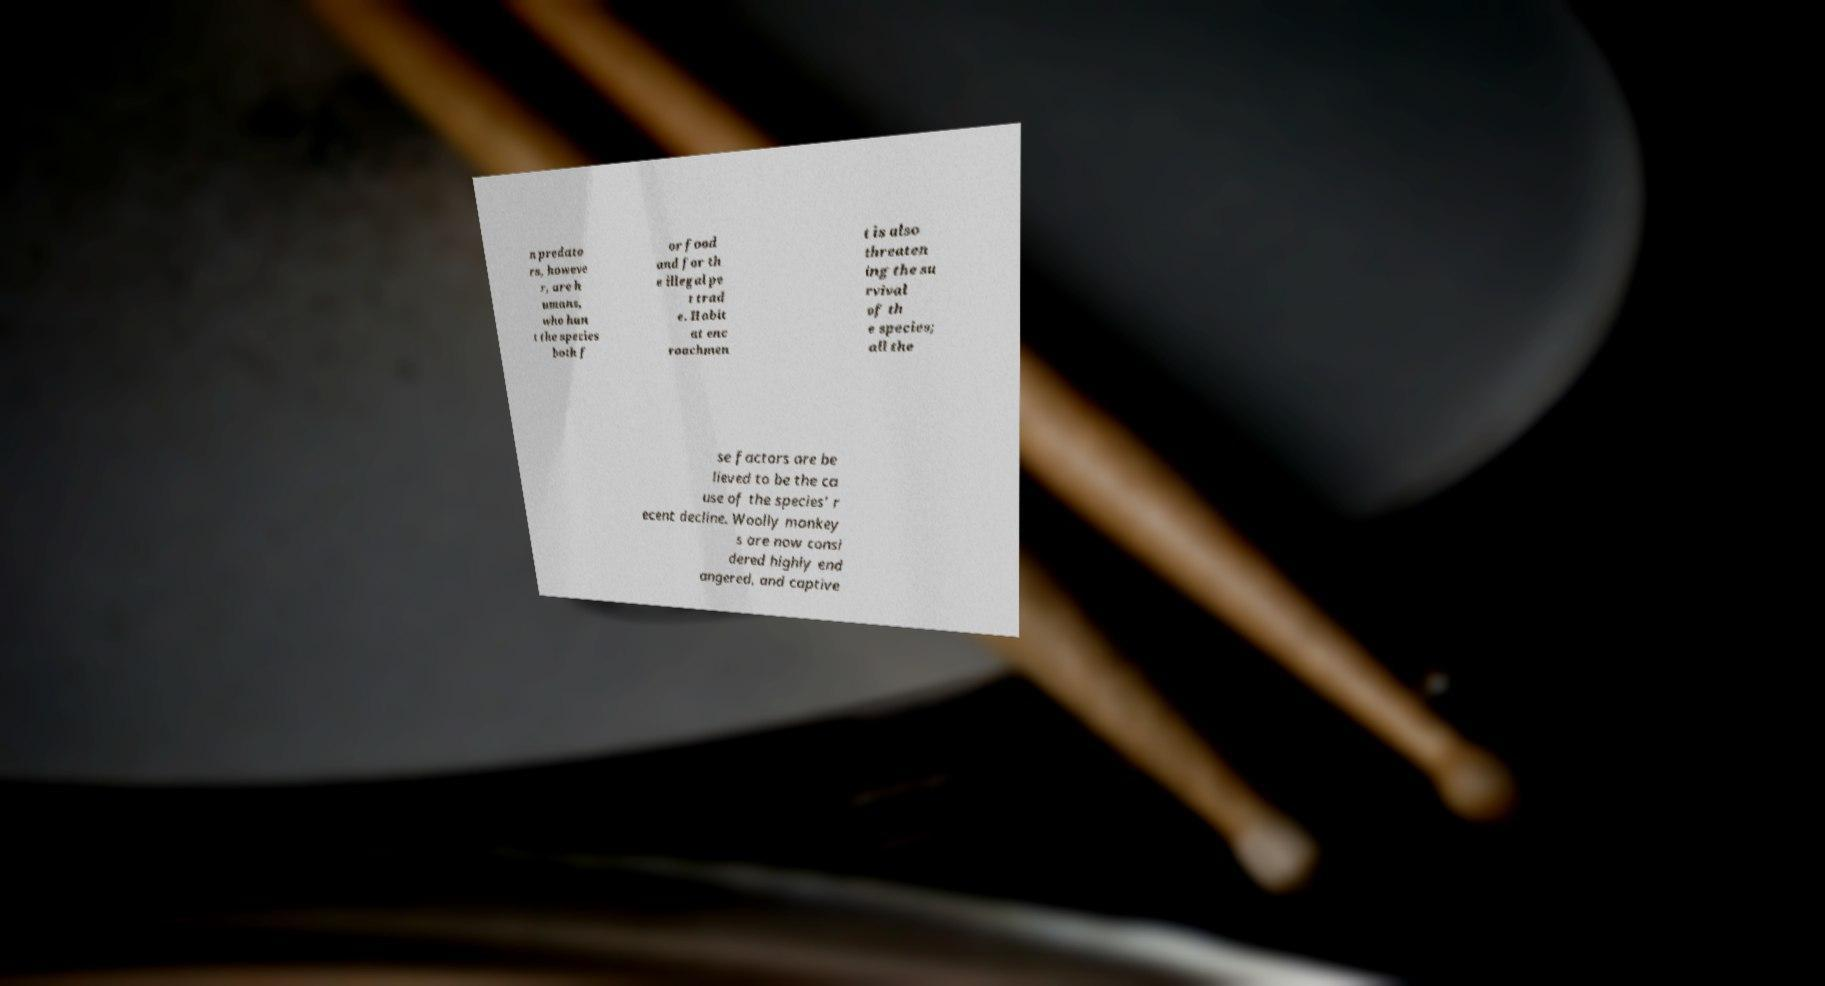I need the written content from this picture converted into text. Can you do that? n predato rs, howeve r, are h umans, who hun t the species both f or food and for th e illegal pe t trad e. Habit at enc roachmen t is also threaten ing the su rvival of th e species; all the se factors are be lieved to be the ca use of the species' r ecent decline. Woolly monkey s are now consi dered highly end angered, and captive 